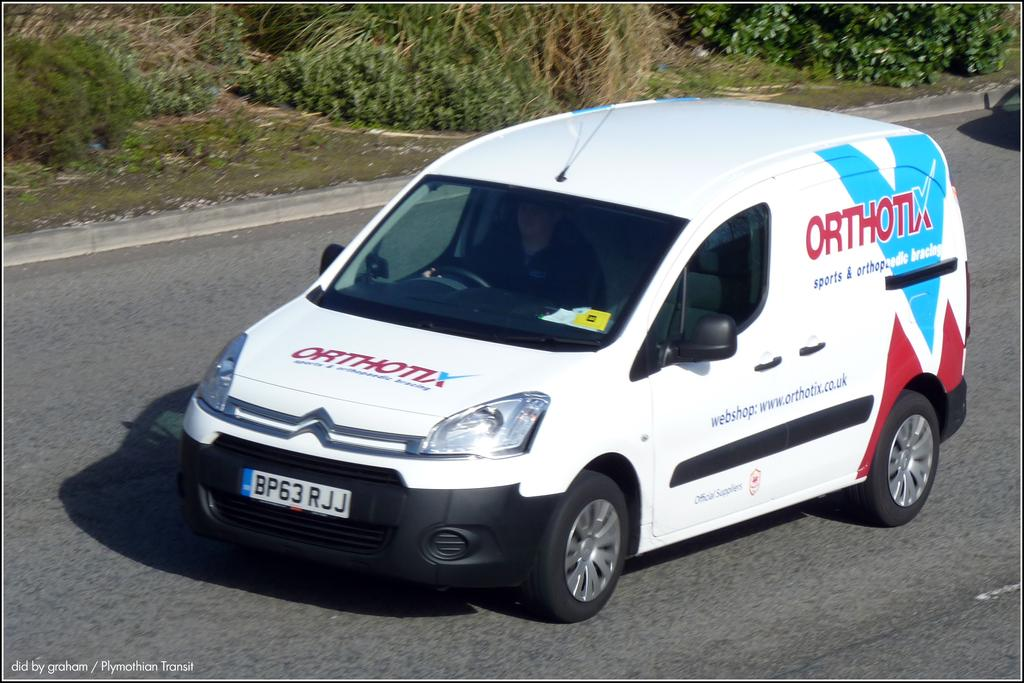<image>
Describe the image concisely. A van with a tag reading BP6 3RJJ on  it. 